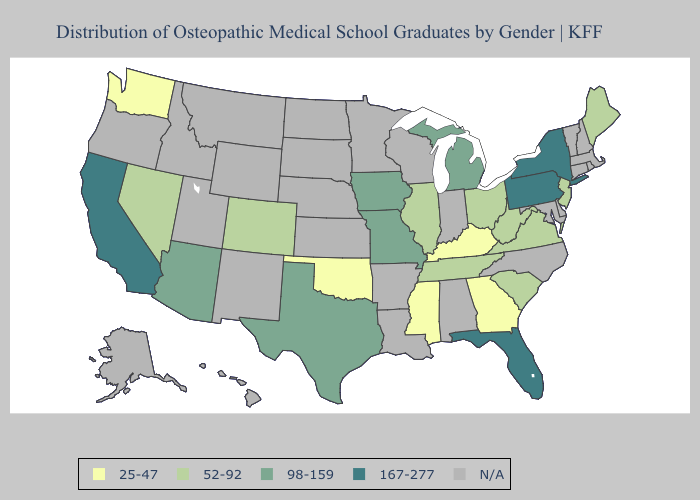What is the value of South Dakota?
Short answer required. N/A. Does Texas have the highest value in the USA?
Short answer required. No. Name the states that have a value in the range 98-159?
Quick response, please. Arizona, Iowa, Michigan, Missouri, Texas. Which states have the highest value in the USA?
Give a very brief answer. California, Florida, New York, Pennsylvania. Name the states that have a value in the range 167-277?
Be succinct. California, Florida, New York, Pennsylvania. What is the value of West Virginia?
Quick response, please. 52-92. What is the highest value in states that border South Dakota?
Quick response, please. 98-159. Does California have the highest value in the West?
Answer briefly. Yes. Which states hav the highest value in the South?
Quick response, please. Florida. Which states hav the highest value in the Northeast?
Be succinct. New York, Pennsylvania. What is the value of Arizona?
Keep it brief. 98-159. Does the map have missing data?
Answer briefly. Yes. 